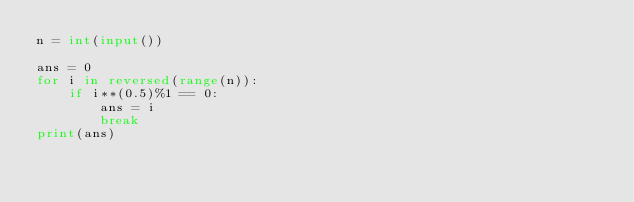<code> <loc_0><loc_0><loc_500><loc_500><_Python_>n = int(input())

ans = 0
for i in reversed(range(n)):
    if i**(0.5)%1 == 0:
        ans = i
        break
print(ans)</code> 